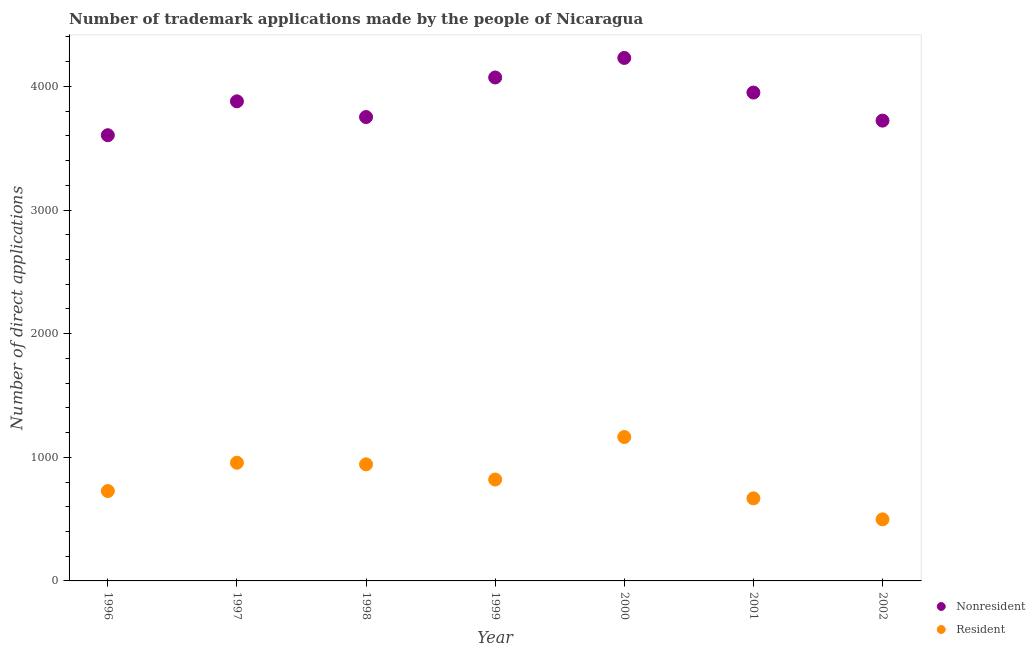How many different coloured dotlines are there?
Give a very brief answer. 2. Is the number of dotlines equal to the number of legend labels?
Make the answer very short. Yes. What is the number of trademark applications made by residents in 1998?
Offer a terse response. 943. Across all years, what is the maximum number of trademark applications made by residents?
Your answer should be very brief. 1164. Across all years, what is the minimum number of trademark applications made by non residents?
Make the answer very short. 3605. What is the total number of trademark applications made by non residents in the graph?
Your answer should be compact. 2.72e+04. What is the difference between the number of trademark applications made by residents in 1998 and that in 2000?
Offer a terse response. -221. What is the difference between the number of trademark applications made by residents in 2001 and the number of trademark applications made by non residents in 1998?
Ensure brevity in your answer.  -3084. What is the average number of trademark applications made by non residents per year?
Your response must be concise. 3887.29. In the year 1997, what is the difference between the number of trademark applications made by residents and number of trademark applications made by non residents?
Your answer should be compact. -2923. In how many years, is the number of trademark applications made by residents greater than 2600?
Your answer should be compact. 0. What is the ratio of the number of trademark applications made by residents in 1998 to that in 2000?
Offer a terse response. 0.81. Is the difference between the number of trademark applications made by non residents in 2000 and 2002 greater than the difference between the number of trademark applications made by residents in 2000 and 2002?
Provide a succinct answer. No. What is the difference between the highest and the second highest number of trademark applications made by non residents?
Your answer should be very brief. 158. What is the difference between the highest and the lowest number of trademark applications made by non residents?
Offer a terse response. 625. In how many years, is the number of trademark applications made by non residents greater than the average number of trademark applications made by non residents taken over all years?
Your answer should be very brief. 3. Is the number of trademark applications made by residents strictly greater than the number of trademark applications made by non residents over the years?
Ensure brevity in your answer.  No. How many years are there in the graph?
Your response must be concise. 7. Does the graph contain any zero values?
Provide a short and direct response. No. How many legend labels are there?
Your answer should be compact. 2. What is the title of the graph?
Offer a very short reply. Number of trademark applications made by the people of Nicaragua. Does "Passenger Transport Items" appear as one of the legend labels in the graph?
Keep it short and to the point. No. What is the label or title of the X-axis?
Your answer should be compact. Year. What is the label or title of the Y-axis?
Offer a terse response. Number of direct applications. What is the Number of direct applications of Nonresident in 1996?
Keep it short and to the point. 3605. What is the Number of direct applications of Resident in 1996?
Your answer should be compact. 727. What is the Number of direct applications of Nonresident in 1997?
Offer a terse response. 3879. What is the Number of direct applications of Resident in 1997?
Your response must be concise. 956. What is the Number of direct applications of Nonresident in 1998?
Keep it short and to the point. 3752. What is the Number of direct applications in Resident in 1998?
Give a very brief answer. 943. What is the Number of direct applications in Nonresident in 1999?
Keep it short and to the point. 4072. What is the Number of direct applications in Resident in 1999?
Ensure brevity in your answer.  820. What is the Number of direct applications of Nonresident in 2000?
Keep it short and to the point. 4230. What is the Number of direct applications of Resident in 2000?
Provide a succinct answer. 1164. What is the Number of direct applications of Nonresident in 2001?
Provide a succinct answer. 3950. What is the Number of direct applications in Resident in 2001?
Offer a very short reply. 668. What is the Number of direct applications in Nonresident in 2002?
Provide a short and direct response. 3723. What is the Number of direct applications in Resident in 2002?
Your response must be concise. 498. Across all years, what is the maximum Number of direct applications of Nonresident?
Give a very brief answer. 4230. Across all years, what is the maximum Number of direct applications of Resident?
Keep it short and to the point. 1164. Across all years, what is the minimum Number of direct applications of Nonresident?
Provide a succinct answer. 3605. Across all years, what is the minimum Number of direct applications of Resident?
Your answer should be very brief. 498. What is the total Number of direct applications in Nonresident in the graph?
Your answer should be compact. 2.72e+04. What is the total Number of direct applications of Resident in the graph?
Keep it short and to the point. 5776. What is the difference between the Number of direct applications in Nonresident in 1996 and that in 1997?
Your answer should be very brief. -274. What is the difference between the Number of direct applications in Resident in 1996 and that in 1997?
Keep it short and to the point. -229. What is the difference between the Number of direct applications of Nonresident in 1996 and that in 1998?
Your response must be concise. -147. What is the difference between the Number of direct applications in Resident in 1996 and that in 1998?
Keep it short and to the point. -216. What is the difference between the Number of direct applications of Nonresident in 1996 and that in 1999?
Your response must be concise. -467. What is the difference between the Number of direct applications of Resident in 1996 and that in 1999?
Make the answer very short. -93. What is the difference between the Number of direct applications in Nonresident in 1996 and that in 2000?
Your answer should be compact. -625. What is the difference between the Number of direct applications of Resident in 1996 and that in 2000?
Provide a succinct answer. -437. What is the difference between the Number of direct applications in Nonresident in 1996 and that in 2001?
Provide a succinct answer. -345. What is the difference between the Number of direct applications of Nonresident in 1996 and that in 2002?
Keep it short and to the point. -118. What is the difference between the Number of direct applications of Resident in 1996 and that in 2002?
Make the answer very short. 229. What is the difference between the Number of direct applications in Nonresident in 1997 and that in 1998?
Your response must be concise. 127. What is the difference between the Number of direct applications of Resident in 1997 and that in 1998?
Offer a terse response. 13. What is the difference between the Number of direct applications of Nonresident in 1997 and that in 1999?
Your response must be concise. -193. What is the difference between the Number of direct applications of Resident in 1997 and that in 1999?
Keep it short and to the point. 136. What is the difference between the Number of direct applications in Nonresident in 1997 and that in 2000?
Provide a succinct answer. -351. What is the difference between the Number of direct applications of Resident in 1997 and that in 2000?
Keep it short and to the point. -208. What is the difference between the Number of direct applications in Nonresident in 1997 and that in 2001?
Your response must be concise. -71. What is the difference between the Number of direct applications of Resident in 1997 and that in 2001?
Ensure brevity in your answer.  288. What is the difference between the Number of direct applications of Nonresident in 1997 and that in 2002?
Offer a very short reply. 156. What is the difference between the Number of direct applications in Resident in 1997 and that in 2002?
Your response must be concise. 458. What is the difference between the Number of direct applications of Nonresident in 1998 and that in 1999?
Offer a very short reply. -320. What is the difference between the Number of direct applications in Resident in 1998 and that in 1999?
Provide a short and direct response. 123. What is the difference between the Number of direct applications in Nonresident in 1998 and that in 2000?
Your response must be concise. -478. What is the difference between the Number of direct applications of Resident in 1998 and that in 2000?
Keep it short and to the point. -221. What is the difference between the Number of direct applications of Nonresident in 1998 and that in 2001?
Keep it short and to the point. -198. What is the difference between the Number of direct applications in Resident in 1998 and that in 2001?
Your response must be concise. 275. What is the difference between the Number of direct applications in Resident in 1998 and that in 2002?
Ensure brevity in your answer.  445. What is the difference between the Number of direct applications in Nonresident in 1999 and that in 2000?
Ensure brevity in your answer.  -158. What is the difference between the Number of direct applications of Resident in 1999 and that in 2000?
Give a very brief answer. -344. What is the difference between the Number of direct applications in Nonresident in 1999 and that in 2001?
Your response must be concise. 122. What is the difference between the Number of direct applications in Resident in 1999 and that in 2001?
Offer a terse response. 152. What is the difference between the Number of direct applications of Nonresident in 1999 and that in 2002?
Your answer should be very brief. 349. What is the difference between the Number of direct applications of Resident in 1999 and that in 2002?
Offer a terse response. 322. What is the difference between the Number of direct applications in Nonresident in 2000 and that in 2001?
Make the answer very short. 280. What is the difference between the Number of direct applications in Resident in 2000 and that in 2001?
Your answer should be compact. 496. What is the difference between the Number of direct applications in Nonresident in 2000 and that in 2002?
Give a very brief answer. 507. What is the difference between the Number of direct applications of Resident in 2000 and that in 2002?
Ensure brevity in your answer.  666. What is the difference between the Number of direct applications in Nonresident in 2001 and that in 2002?
Keep it short and to the point. 227. What is the difference between the Number of direct applications of Resident in 2001 and that in 2002?
Offer a terse response. 170. What is the difference between the Number of direct applications in Nonresident in 1996 and the Number of direct applications in Resident in 1997?
Your answer should be compact. 2649. What is the difference between the Number of direct applications of Nonresident in 1996 and the Number of direct applications of Resident in 1998?
Offer a very short reply. 2662. What is the difference between the Number of direct applications in Nonresident in 1996 and the Number of direct applications in Resident in 1999?
Give a very brief answer. 2785. What is the difference between the Number of direct applications in Nonresident in 1996 and the Number of direct applications in Resident in 2000?
Offer a terse response. 2441. What is the difference between the Number of direct applications of Nonresident in 1996 and the Number of direct applications of Resident in 2001?
Give a very brief answer. 2937. What is the difference between the Number of direct applications of Nonresident in 1996 and the Number of direct applications of Resident in 2002?
Offer a very short reply. 3107. What is the difference between the Number of direct applications of Nonresident in 1997 and the Number of direct applications of Resident in 1998?
Provide a short and direct response. 2936. What is the difference between the Number of direct applications of Nonresident in 1997 and the Number of direct applications of Resident in 1999?
Make the answer very short. 3059. What is the difference between the Number of direct applications in Nonresident in 1997 and the Number of direct applications in Resident in 2000?
Make the answer very short. 2715. What is the difference between the Number of direct applications in Nonresident in 1997 and the Number of direct applications in Resident in 2001?
Offer a terse response. 3211. What is the difference between the Number of direct applications of Nonresident in 1997 and the Number of direct applications of Resident in 2002?
Ensure brevity in your answer.  3381. What is the difference between the Number of direct applications in Nonresident in 1998 and the Number of direct applications in Resident in 1999?
Ensure brevity in your answer.  2932. What is the difference between the Number of direct applications of Nonresident in 1998 and the Number of direct applications of Resident in 2000?
Ensure brevity in your answer.  2588. What is the difference between the Number of direct applications in Nonresident in 1998 and the Number of direct applications in Resident in 2001?
Your answer should be compact. 3084. What is the difference between the Number of direct applications of Nonresident in 1998 and the Number of direct applications of Resident in 2002?
Keep it short and to the point. 3254. What is the difference between the Number of direct applications in Nonresident in 1999 and the Number of direct applications in Resident in 2000?
Ensure brevity in your answer.  2908. What is the difference between the Number of direct applications of Nonresident in 1999 and the Number of direct applications of Resident in 2001?
Give a very brief answer. 3404. What is the difference between the Number of direct applications of Nonresident in 1999 and the Number of direct applications of Resident in 2002?
Give a very brief answer. 3574. What is the difference between the Number of direct applications of Nonresident in 2000 and the Number of direct applications of Resident in 2001?
Provide a succinct answer. 3562. What is the difference between the Number of direct applications of Nonresident in 2000 and the Number of direct applications of Resident in 2002?
Your answer should be compact. 3732. What is the difference between the Number of direct applications in Nonresident in 2001 and the Number of direct applications in Resident in 2002?
Offer a terse response. 3452. What is the average Number of direct applications in Nonresident per year?
Ensure brevity in your answer.  3887.29. What is the average Number of direct applications in Resident per year?
Your answer should be compact. 825.14. In the year 1996, what is the difference between the Number of direct applications in Nonresident and Number of direct applications in Resident?
Ensure brevity in your answer.  2878. In the year 1997, what is the difference between the Number of direct applications in Nonresident and Number of direct applications in Resident?
Offer a terse response. 2923. In the year 1998, what is the difference between the Number of direct applications of Nonresident and Number of direct applications of Resident?
Your answer should be compact. 2809. In the year 1999, what is the difference between the Number of direct applications in Nonresident and Number of direct applications in Resident?
Keep it short and to the point. 3252. In the year 2000, what is the difference between the Number of direct applications in Nonresident and Number of direct applications in Resident?
Keep it short and to the point. 3066. In the year 2001, what is the difference between the Number of direct applications of Nonresident and Number of direct applications of Resident?
Keep it short and to the point. 3282. In the year 2002, what is the difference between the Number of direct applications of Nonresident and Number of direct applications of Resident?
Give a very brief answer. 3225. What is the ratio of the Number of direct applications in Nonresident in 1996 to that in 1997?
Offer a terse response. 0.93. What is the ratio of the Number of direct applications in Resident in 1996 to that in 1997?
Provide a succinct answer. 0.76. What is the ratio of the Number of direct applications of Nonresident in 1996 to that in 1998?
Your answer should be very brief. 0.96. What is the ratio of the Number of direct applications in Resident in 1996 to that in 1998?
Provide a short and direct response. 0.77. What is the ratio of the Number of direct applications in Nonresident in 1996 to that in 1999?
Offer a very short reply. 0.89. What is the ratio of the Number of direct applications of Resident in 1996 to that in 1999?
Provide a short and direct response. 0.89. What is the ratio of the Number of direct applications in Nonresident in 1996 to that in 2000?
Offer a very short reply. 0.85. What is the ratio of the Number of direct applications in Resident in 1996 to that in 2000?
Make the answer very short. 0.62. What is the ratio of the Number of direct applications in Nonresident in 1996 to that in 2001?
Your response must be concise. 0.91. What is the ratio of the Number of direct applications of Resident in 1996 to that in 2001?
Provide a succinct answer. 1.09. What is the ratio of the Number of direct applications of Nonresident in 1996 to that in 2002?
Offer a very short reply. 0.97. What is the ratio of the Number of direct applications of Resident in 1996 to that in 2002?
Offer a very short reply. 1.46. What is the ratio of the Number of direct applications in Nonresident in 1997 to that in 1998?
Give a very brief answer. 1.03. What is the ratio of the Number of direct applications in Resident in 1997 to that in 1998?
Provide a succinct answer. 1.01. What is the ratio of the Number of direct applications in Nonresident in 1997 to that in 1999?
Your answer should be compact. 0.95. What is the ratio of the Number of direct applications in Resident in 1997 to that in 1999?
Your answer should be compact. 1.17. What is the ratio of the Number of direct applications of Nonresident in 1997 to that in 2000?
Your answer should be very brief. 0.92. What is the ratio of the Number of direct applications of Resident in 1997 to that in 2000?
Provide a succinct answer. 0.82. What is the ratio of the Number of direct applications in Nonresident in 1997 to that in 2001?
Offer a very short reply. 0.98. What is the ratio of the Number of direct applications of Resident in 1997 to that in 2001?
Provide a short and direct response. 1.43. What is the ratio of the Number of direct applications in Nonresident in 1997 to that in 2002?
Your answer should be very brief. 1.04. What is the ratio of the Number of direct applications of Resident in 1997 to that in 2002?
Ensure brevity in your answer.  1.92. What is the ratio of the Number of direct applications in Nonresident in 1998 to that in 1999?
Your response must be concise. 0.92. What is the ratio of the Number of direct applications in Resident in 1998 to that in 1999?
Make the answer very short. 1.15. What is the ratio of the Number of direct applications of Nonresident in 1998 to that in 2000?
Offer a terse response. 0.89. What is the ratio of the Number of direct applications of Resident in 1998 to that in 2000?
Ensure brevity in your answer.  0.81. What is the ratio of the Number of direct applications in Nonresident in 1998 to that in 2001?
Your answer should be compact. 0.95. What is the ratio of the Number of direct applications of Resident in 1998 to that in 2001?
Offer a very short reply. 1.41. What is the ratio of the Number of direct applications in Resident in 1998 to that in 2002?
Ensure brevity in your answer.  1.89. What is the ratio of the Number of direct applications of Nonresident in 1999 to that in 2000?
Offer a terse response. 0.96. What is the ratio of the Number of direct applications in Resident in 1999 to that in 2000?
Ensure brevity in your answer.  0.7. What is the ratio of the Number of direct applications of Nonresident in 1999 to that in 2001?
Give a very brief answer. 1.03. What is the ratio of the Number of direct applications of Resident in 1999 to that in 2001?
Your answer should be compact. 1.23. What is the ratio of the Number of direct applications in Nonresident in 1999 to that in 2002?
Provide a short and direct response. 1.09. What is the ratio of the Number of direct applications of Resident in 1999 to that in 2002?
Offer a very short reply. 1.65. What is the ratio of the Number of direct applications in Nonresident in 2000 to that in 2001?
Keep it short and to the point. 1.07. What is the ratio of the Number of direct applications of Resident in 2000 to that in 2001?
Your answer should be very brief. 1.74. What is the ratio of the Number of direct applications in Nonresident in 2000 to that in 2002?
Keep it short and to the point. 1.14. What is the ratio of the Number of direct applications in Resident in 2000 to that in 2002?
Offer a very short reply. 2.34. What is the ratio of the Number of direct applications in Nonresident in 2001 to that in 2002?
Provide a short and direct response. 1.06. What is the ratio of the Number of direct applications in Resident in 2001 to that in 2002?
Provide a short and direct response. 1.34. What is the difference between the highest and the second highest Number of direct applications in Nonresident?
Offer a very short reply. 158. What is the difference between the highest and the second highest Number of direct applications of Resident?
Provide a succinct answer. 208. What is the difference between the highest and the lowest Number of direct applications in Nonresident?
Your answer should be compact. 625. What is the difference between the highest and the lowest Number of direct applications of Resident?
Provide a succinct answer. 666. 